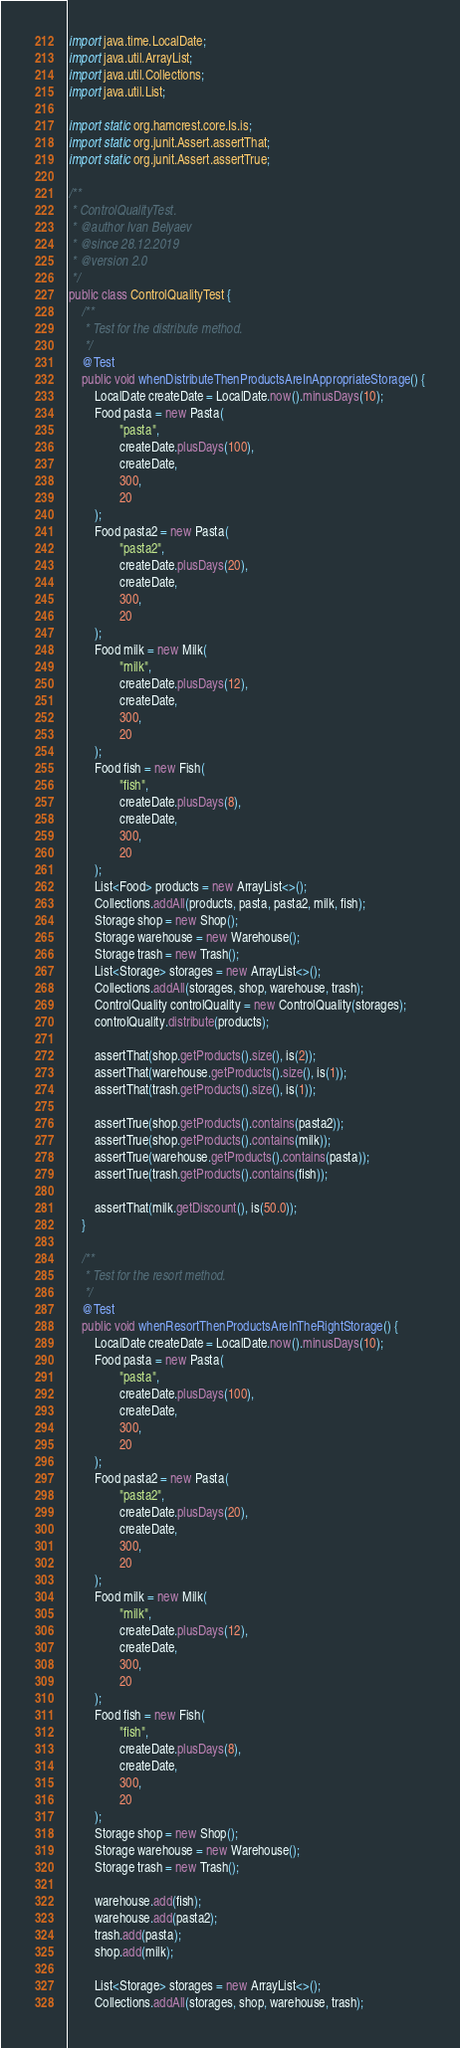Convert code to text. <code><loc_0><loc_0><loc_500><loc_500><_Java_>
import java.time.LocalDate;
import java.util.ArrayList;
import java.util.Collections;
import java.util.List;

import static org.hamcrest.core.Is.is;
import static org.junit.Assert.assertThat;
import static org.junit.Assert.assertTrue;

/**
 * ControlQualityTest.
 * @author Ivan Belyaev
 * @since 28.12.2019
 * @version 2.0
 */
public class ControlQualityTest {
    /**
     * Test for the distribute method.
     */
    @Test
    public void whenDistributeThenProductsAreInAppropriateStorage() {
        LocalDate createDate = LocalDate.now().minusDays(10);
        Food pasta = new Pasta(
                "pasta",
                createDate.plusDays(100),
                createDate,
                300,
                20
        );
        Food pasta2 = new Pasta(
                "pasta2",
                createDate.plusDays(20),
                createDate,
                300,
                20
        );
        Food milk = new Milk(
                "milk",
                createDate.plusDays(12),
                createDate,
                300,
                20
        );
        Food fish = new Fish(
                "fish",
                createDate.plusDays(8),
                createDate,
                300,
                20
        );
        List<Food> products = new ArrayList<>();
        Collections.addAll(products, pasta, pasta2, milk, fish);
        Storage shop = new Shop();
        Storage warehouse = new Warehouse();
        Storage trash = new Trash();
        List<Storage> storages = new ArrayList<>();
        Collections.addAll(storages, shop, warehouse, trash);
        ControlQuality controlQuality = new ControlQuality(storages);
        controlQuality.distribute(products);

        assertThat(shop.getProducts().size(), is(2));
        assertThat(warehouse.getProducts().size(), is(1));
        assertThat(trash.getProducts().size(), is(1));

        assertTrue(shop.getProducts().contains(pasta2));
        assertTrue(shop.getProducts().contains(milk));
        assertTrue(warehouse.getProducts().contains(pasta));
        assertTrue(trash.getProducts().contains(fish));

        assertThat(milk.getDiscount(), is(50.0));
    }

    /**
     * Test for the resort method.
     */
    @Test
    public void whenResortThenProductsAreInTheRightStorage() {
        LocalDate createDate = LocalDate.now().minusDays(10);
        Food pasta = new Pasta(
                "pasta",
                createDate.plusDays(100),
                createDate,
                300,
                20
        );
        Food pasta2 = new Pasta(
                "pasta2",
                createDate.plusDays(20),
                createDate,
                300,
                20
        );
        Food milk = new Milk(
                "milk",
                createDate.plusDays(12),
                createDate,
                300,
                20
        );
        Food fish = new Fish(
                "fish",
                createDate.plusDays(8),
                createDate,
                300,
                20
        );
        Storage shop = new Shop();
        Storage warehouse = new Warehouse();
        Storage trash = new Trash();

        warehouse.add(fish);
        warehouse.add(pasta2);
        trash.add(pasta);
        shop.add(milk);

        List<Storage> storages = new ArrayList<>();
        Collections.addAll(storages, shop, warehouse, trash);</code> 